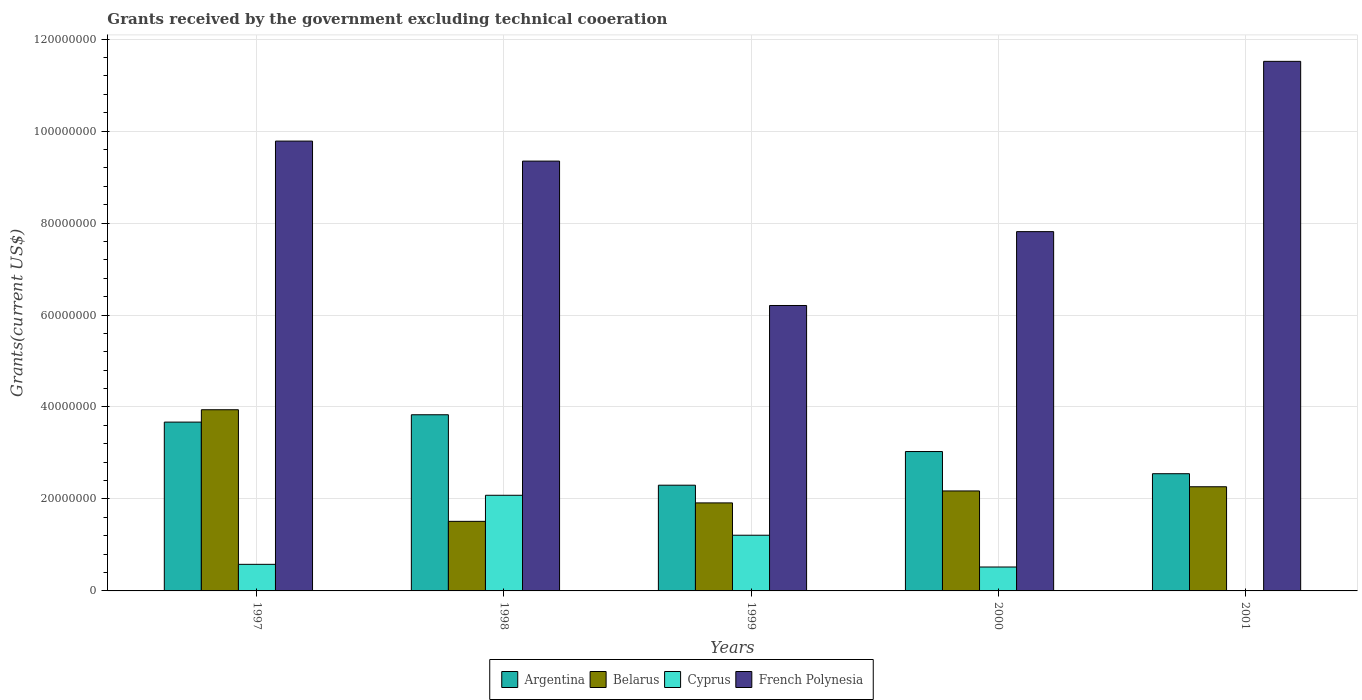How many bars are there on the 3rd tick from the left?
Offer a terse response. 4. What is the total grants received by the government in Cyprus in 1999?
Provide a succinct answer. 1.21e+07. Across all years, what is the maximum total grants received by the government in Belarus?
Offer a terse response. 3.94e+07. In which year was the total grants received by the government in Belarus maximum?
Keep it short and to the point. 1997. What is the total total grants received by the government in Belarus in the graph?
Ensure brevity in your answer.  1.18e+08. What is the difference between the total grants received by the government in French Polynesia in 1999 and that in 2001?
Offer a terse response. -5.31e+07. What is the difference between the total grants received by the government in French Polynesia in 2000 and the total grants received by the government in Belarus in 1999?
Provide a succinct answer. 5.90e+07. What is the average total grants received by the government in Cyprus per year?
Keep it short and to the point. 8.78e+06. In the year 2000, what is the difference between the total grants received by the government in Belarus and total grants received by the government in Cyprus?
Provide a succinct answer. 1.65e+07. In how many years, is the total grants received by the government in French Polynesia greater than 68000000 US$?
Your answer should be compact. 4. What is the ratio of the total grants received by the government in Argentina in 1997 to that in 2001?
Keep it short and to the point. 1.44. Is the difference between the total grants received by the government in Belarus in 1999 and 2000 greater than the difference between the total grants received by the government in Cyprus in 1999 and 2000?
Offer a very short reply. No. What is the difference between the highest and the second highest total grants received by the government in Argentina?
Offer a very short reply. 1.60e+06. What is the difference between the highest and the lowest total grants received by the government in Argentina?
Your response must be concise. 1.53e+07. Is it the case that in every year, the sum of the total grants received by the government in Belarus and total grants received by the government in Cyprus is greater than the sum of total grants received by the government in Argentina and total grants received by the government in French Polynesia?
Ensure brevity in your answer.  Yes. Is it the case that in every year, the sum of the total grants received by the government in Belarus and total grants received by the government in Cyprus is greater than the total grants received by the government in French Polynesia?
Make the answer very short. No. Are all the bars in the graph horizontal?
Ensure brevity in your answer.  No. What is the difference between two consecutive major ticks on the Y-axis?
Offer a terse response. 2.00e+07. Are the values on the major ticks of Y-axis written in scientific E-notation?
Keep it short and to the point. No. Does the graph contain any zero values?
Provide a short and direct response. Yes. Does the graph contain grids?
Provide a succinct answer. Yes. How are the legend labels stacked?
Provide a succinct answer. Horizontal. What is the title of the graph?
Offer a terse response. Grants received by the government excluding technical cooeration. What is the label or title of the X-axis?
Your answer should be compact. Years. What is the label or title of the Y-axis?
Provide a short and direct response. Grants(current US$). What is the Grants(current US$) in Argentina in 1997?
Make the answer very short. 3.67e+07. What is the Grants(current US$) of Belarus in 1997?
Offer a terse response. 3.94e+07. What is the Grants(current US$) of Cyprus in 1997?
Keep it short and to the point. 5.78e+06. What is the Grants(current US$) of French Polynesia in 1997?
Your answer should be very brief. 9.78e+07. What is the Grants(current US$) of Argentina in 1998?
Your answer should be compact. 3.83e+07. What is the Grants(current US$) of Belarus in 1998?
Ensure brevity in your answer.  1.51e+07. What is the Grants(current US$) of Cyprus in 1998?
Provide a short and direct response. 2.08e+07. What is the Grants(current US$) in French Polynesia in 1998?
Provide a succinct answer. 9.35e+07. What is the Grants(current US$) in Argentina in 1999?
Your answer should be compact. 2.30e+07. What is the Grants(current US$) in Belarus in 1999?
Give a very brief answer. 1.91e+07. What is the Grants(current US$) of Cyprus in 1999?
Give a very brief answer. 1.21e+07. What is the Grants(current US$) in French Polynesia in 1999?
Offer a terse response. 6.21e+07. What is the Grants(current US$) of Argentina in 2000?
Offer a very short reply. 3.03e+07. What is the Grants(current US$) in Belarus in 2000?
Provide a short and direct response. 2.17e+07. What is the Grants(current US$) of Cyprus in 2000?
Provide a succinct answer. 5.20e+06. What is the Grants(current US$) in French Polynesia in 2000?
Your response must be concise. 7.81e+07. What is the Grants(current US$) of Argentina in 2001?
Ensure brevity in your answer.  2.55e+07. What is the Grants(current US$) in Belarus in 2001?
Keep it short and to the point. 2.26e+07. What is the Grants(current US$) of Cyprus in 2001?
Your response must be concise. 0. What is the Grants(current US$) of French Polynesia in 2001?
Make the answer very short. 1.15e+08. Across all years, what is the maximum Grants(current US$) of Argentina?
Your response must be concise. 3.83e+07. Across all years, what is the maximum Grants(current US$) of Belarus?
Your response must be concise. 3.94e+07. Across all years, what is the maximum Grants(current US$) in Cyprus?
Ensure brevity in your answer.  2.08e+07. Across all years, what is the maximum Grants(current US$) of French Polynesia?
Your answer should be very brief. 1.15e+08. Across all years, what is the minimum Grants(current US$) in Argentina?
Ensure brevity in your answer.  2.30e+07. Across all years, what is the minimum Grants(current US$) of Belarus?
Make the answer very short. 1.51e+07. Across all years, what is the minimum Grants(current US$) of Cyprus?
Give a very brief answer. 0. Across all years, what is the minimum Grants(current US$) in French Polynesia?
Provide a succinct answer. 6.21e+07. What is the total Grants(current US$) in Argentina in the graph?
Your response must be concise. 1.54e+08. What is the total Grants(current US$) in Belarus in the graph?
Give a very brief answer. 1.18e+08. What is the total Grants(current US$) in Cyprus in the graph?
Provide a succinct answer. 4.39e+07. What is the total Grants(current US$) in French Polynesia in the graph?
Provide a succinct answer. 4.47e+08. What is the difference between the Grants(current US$) in Argentina in 1997 and that in 1998?
Offer a terse response. -1.60e+06. What is the difference between the Grants(current US$) of Belarus in 1997 and that in 1998?
Provide a succinct answer. 2.43e+07. What is the difference between the Grants(current US$) of Cyprus in 1997 and that in 1998?
Offer a terse response. -1.50e+07. What is the difference between the Grants(current US$) in French Polynesia in 1997 and that in 1998?
Ensure brevity in your answer.  4.35e+06. What is the difference between the Grants(current US$) in Argentina in 1997 and that in 1999?
Give a very brief answer. 1.37e+07. What is the difference between the Grants(current US$) of Belarus in 1997 and that in 1999?
Offer a terse response. 2.03e+07. What is the difference between the Grants(current US$) of Cyprus in 1997 and that in 1999?
Your answer should be compact. -6.33e+06. What is the difference between the Grants(current US$) of French Polynesia in 1997 and that in 1999?
Offer a very short reply. 3.58e+07. What is the difference between the Grants(current US$) of Argentina in 1997 and that in 2000?
Your response must be concise. 6.40e+06. What is the difference between the Grants(current US$) in Belarus in 1997 and that in 2000?
Ensure brevity in your answer.  1.77e+07. What is the difference between the Grants(current US$) of Cyprus in 1997 and that in 2000?
Your response must be concise. 5.80e+05. What is the difference between the Grants(current US$) in French Polynesia in 1997 and that in 2000?
Ensure brevity in your answer.  1.97e+07. What is the difference between the Grants(current US$) in Argentina in 1997 and that in 2001?
Ensure brevity in your answer.  1.12e+07. What is the difference between the Grants(current US$) in Belarus in 1997 and that in 2001?
Provide a succinct answer. 1.68e+07. What is the difference between the Grants(current US$) of French Polynesia in 1997 and that in 2001?
Your answer should be compact. -1.73e+07. What is the difference between the Grants(current US$) in Argentina in 1998 and that in 1999?
Provide a short and direct response. 1.53e+07. What is the difference between the Grants(current US$) in Belarus in 1998 and that in 1999?
Provide a succinct answer. -4.01e+06. What is the difference between the Grants(current US$) of Cyprus in 1998 and that in 1999?
Your answer should be compact. 8.69e+06. What is the difference between the Grants(current US$) of French Polynesia in 1998 and that in 1999?
Provide a succinct answer. 3.14e+07. What is the difference between the Grants(current US$) of Argentina in 1998 and that in 2000?
Ensure brevity in your answer.  8.00e+06. What is the difference between the Grants(current US$) in Belarus in 1998 and that in 2000?
Give a very brief answer. -6.61e+06. What is the difference between the Grants(current US$) of Cyprus in 1998 and that in 2000?
Make the answer very short. 1.56e+07. What is the difference between the Grants(current US$) in French Polynesia in 1998 and that in 2000?
Keep it short and to the point. 1.53e+07. What is the difference between the Grants(current US$) of Argentina in 1998 and that in 2001?
Provide a succinct answer. 1.28e+07. What is the difference between the Grants(current US$) in Belarus in 1998 and that in 2001?
Your answer should be very brief. -7.52e+06. What is the difference between the Grants(current US$) of French Polynesia in 1998 and that in 2001?
Keep it short and to the point. -2.17e+07. What is the difference between the Grants(current US$) in Argentina in 1999 and that in 2000?
Ensure brevity in your answer.  -7.32e+06. What is the difference between the Grants(current US$) of Belarus in 1999 and that in 2000?
Offer a very short reply. -2.60e+06. What is the difference between the Grants(current US$) in Cyprus in 1999 and that in 2000?
Ensure brevity in your answer.  6.91e+06. What is the difference between the Grants(current US$) in French Polynesia in 1999 and that in 2000?
Provide a short and direct response. -1.61e+07. What is the difference between the Grants(current US$) of Argentina in 1999 and that in 2001?
Provide a succinct answer. -2.50e+06. What is the difference between the Grants(current US$) of Belarus in 1999 and that in 2001?
Offer a very short reply. -3.51e+06. What is the difference between the Grants(current US$) in French Polynesia in 1999 and that in 2001?
Ensure brevity in your answer.  -5.31e+07. What is the difference between the Grants(current US$) in Argentina in 2000 and that in 2001?
Offer a very short reply. 4.82e+06. What is the difference between the Grants(current US$) in Belarus in 2000 and that in 2001?
Offer a terse response. -9.10e+05. What is the difference between the Grants(current US$) in French Polynesia in 2000 and that in 2001?
Provide a succinct answer. -3.70e+07. What is the difference between the Grants(current US$) of Argentina in 1997 and the Grants(current US$) of Belarus in 1998?
Give a very brief answer. 2.16e+07. What is the difference between the Grants(current US$) in Argentina in 1997 and the Grants(current US$) in Cyprus in 1998?
Your answer should be very brief. 1.59e+07. What is the difference between the Grants(current US$) of Argentina in 1997 and the Grants(current US$) of French Polynesia in 1998?
Offer a very short reply. -5.68e+07. What is the difference between the Grants(current US$) in Belarus in 1997 and the Grants(current US$) in Cyprus in 1998?
Offer a very short reply. 1.86e+07. What is the difference between the Grants(current US$) of Belarus in 1997 and the Grants(current US$) of French Polynesia in 1998?
Make the answer very short. -5.41e+07. What is the difference between the Grants(current US$) in Cyprus in 1997 and the Grants(current US$) in French Polynesia in 1998?
Offer a very short reply. -8.77e+07. What is the difference between the Grants(current US$) in Argentina in 1997 and the Grants(current US$) in Belarus in 1999?
Your response must be concise. 1.76e+07. What is the difference between the Grants(current US$) in Argentina in 1997 and the Grants(current US$) in Cyprus in 1999?
Offer a terse response. 2.46e+07. What is the difference between the Grants(current US$) in Argentina in 1997 and the Grants(current US$) in French Polynesia in 1999?
Give a very brief answer. -2.54e+07. What is the difference between the Grants(current US$) of Belarus in 1997 and the Grants(current US$) of Cyprus in 1999?
Make the answer very short. 2.73e+07. What is the difference between the Grants(current US$) in Belarus in 1997 and the Grants(current US$) in French Polynesia in 1999?
Your answer should be very brief. -2.27e+07. What is the difference between the Grants(current US$) of Cyprus in 1997 and the Grants(current US$) of French Polynesia in 1999?
Your answer should be compact. -5.63e+07. What is the difference between the Grants(current US$) in Argentina in 1997 and the Grants(current US$) in Belarus in 2000?
Offer a terse response. 1.50e+07. What is the difference between the Grants(current US$) of Argentina in 1997 and the Grants(current US$) of Cyprus in 2000?
Your response must be concise. 3.15e+07. What is the difference between the Grants(current US$) of Argentina in 1997 and the Grants(current US$) of French Polynesia in 2000?
Your response must be concise. -4.14e+07. What is the difference between the Grants(current US$) of Belarus in 1997 and the Grants(current US$) of Cyprus in 2000?
Offer a very short reply. 3.42e+07. What is the difference between the Grants(current US$) of Belarus in 1997 and the Grants(current US$) of French Polynesia in 2000?
Make the answer very short. -3.87e+07. What is the difference between the Grants(current US$) in Cyprus in 1997 and the Grants(current US$) in French Polynesia in 2000?
Offer a very short reply. -7.24e+07. What is the difference between the Grants(current US$) in Argentina in 1997 and the Grants(current US$) in Belarus in 2001?
Offer a terse response. 1.41e+07. What is the difference between the Grants(current US$) of Argentina in 1997 and the Grants(current US$) of French Polynesia in 2001?
Give a very brief answer. -7.84e+07. What is the difference between the Grants(current US$) of Belarus in 1997 and the Grants(current US$) of French Polynesia in 2001?
Offer a very short reply. -7.58e+07. What is the difference between the Grants(current US$) of Cyprus in 1997 and the Grants(current US$) of French Polynesia in 2001?
Ensure brevity in your answer.  -1.09e+08. What is the difference between the Grants(current US$) in Argentina in 1998 and the Grants(current US$) in Belarus in 1999?
Ensure brevity in your answer.  1.92e+07. What is the difference between the Grants(current US$) in Argentina in 1998 and the Grants(current US$) in Cyprus in 1999?
Your answer should be compact. 2.62e+07. What is the difference between the Grants(current US$) in Argentina in 1998 and the Grants(current US$) in French Polynesia in 1999?
Keep it short and to the point. -2.38e+07. What is the difference between the Grants(current US$) of Belarus in 1998 and the Grants(current US$) of Cyprus in 1999?
Ensure brevity in your answer.  3.02e+06. What is the difference between the Grants(current US$) of Belarus in 1998 and the Grants(current US$) of French Polynesia in 1999?
Provide a short and direct response. -4.69e+07. What is the difference between the Grants(current US$) of Cyprus in 1998 and the Grants(current US$) of French Polynesia in 1999?
Your response must be concise. -4.13e+07. What is the difference between the Grants(current US$) in Argentina in 1998 and the Grants(current US$) in Belarus in 2000?
Keep it short and to the point. 1.66e+07. What is the difference between the Grants(current US$) in Argentina in 1998 and the Grants(current US$) in Cyprus in 2000?
Make the answer very short. 3.31e+07. What is the difference between the Grants(current US$) in Argentina in 1998 and the Grants(current US$) in French Polynesia in 2000?
Keep it short and to the point. -3.98e+07. What is the difference between the Grants(current US$) of Belarus in 1998 and the Grants(current US$) of Cyprus in 2000?
Keep it short and to the point. 9.93e+06. What is the difference between the Grants(current US$) of Belarus in 1998 and the Grants(current US$) of French Polynesia in 2000?
Provide a succinct answer. -6.30e+07. What is the difference between the Grants(current US$) in Cyprus in 1998 and the Grants(current US$) in French Polynesia in 2000?
Make the answer very short. -5.73e+07. What is the difference between the Grants(current US$) in Argentina in 1998 and the Grants(current US$) in Belarus in 2001?
Your answer should be very brief. 1.57e+07. What is the difference between the Grants(current US$) in Argentina in 1998 and the Grants(current US$) in French Polynesia in 2001?
Provide a succinct answer. -7.68e+07. What is the difference between the Grants(current US$) of Belarus in 1998 and the Grants(current US$) of French Polynesia in 2001?
Offer a terse response. -1.00e+08. What is the difference between the Grants(current US$) in Cyprus in 1998 and the Grants(current US$) in French Polynesia in 2001?
Your answer should be very brief. -9.44e+07. What is the difference between the Grants(current US$) of Argentina in 1999 and the Grants(current US$) of Belarus in 2000?
Your response must be concise. 1.25e+06. What is the difference between the Grants(current US$) of Argentina in 1999 and the Grants(current US$) of Cyprus in 2000?
Your answer should be compact. 1.78e+07. What is the difference between the Grants(current US$) in Argentina in 1999 and the Grants(current US$) in French Polynesia in 2000?
Keep it short and to the point. -5.51e+07. What is the difference between the Grants(current US$) in Belarus in 1999 and the Grants(current US$) in Cyprus in 2000?
Give a very brief answer. 1.39e+07. What is the difference between the Grants(current US$) in Belarus in 1999 and the Grants(current US$) in French Polynesia in 2000?
Keep it short and to the point. -5.90e+07. What is the difference between the Grants(current US$) in Cyprus in 1999 and the Grants(current US$) in French Polynesia in 2000?
Give a very brief answer. -6.60e+07. What is the difference between the Grants(current US$) in Argentina in 1999 and the Grants(current US$) in French Polynesia in 2001?
Offer a very short reply. -9.22e+07. What is the difference between the Grants(current US$) of Belarus in 1999 and the Grants(current US$) of French Polynesia in 2001?
Offer a very short reply. -9.60e+07. What is the difference between the Grants(current US$) in Cyprus in 1999 and the Grants(current US$) in French Polynesia in 2001?
Provide a succinct answer. -1.03e+08. What is the difference between the Grants(current US$) of Argentina in 2000 and the Grants(current US$) of Belarus in 2001?
Keep it short and to the point. 7.66e+06. What is the difference between the Grants(current US$) in Argentina in 2000 and the Grants(current US$) in French Polynesia in 2001?
Make the answer very short. -8.48e+07. What is the difference between the Grants(current US$) of Belarus in 2000 and the Grants(current US$) of French Polynesia in 2001?
Your answer should be very brief. -9.34e+07. What is the difference between the Grants(current US$) of Cyprus in 2000 and the Grants(current US$) of French Polynesia in 2001?
Offer a very short reply. -1.10e+08. What is the average Grants(current US$) of Argentina per year?
Your response must be concise. 3.08e+07. What is the average Grants(current US$) of Belarus per year?
Offer a very short reply. 2.36e+07. What is the average Grants(current US$) in Cyprus per year?
Give a very brief answer. 8.78e+06. What is the average Grants(current US$) in French Polynesia per year?
Offer a very short reply. 8.93e+07. In the year 1997, what is the difference between the Grants(current US$) of Argentina and Grants(current US$) of Belarus?
Keep it short and to the point. -2.69e+06. In the year 1997, what is the difference between the Grants(current US$) in Argentina and Grants(current US$) in Cyprus?
Provide a short and direct response. 3.09e+07. In the year 1997, what is the difference between the Grants(current US$) of Argentina and Grants(current US$) of French Polynesia?
Offer a terse response. -6.11e+07. In the year 1997, what is the difference between the Grants(current US$) in Belarus and Grants(current US$) in Cyprus?
Provide a short and direct response. 3.36e+07. In the year 1997, what is the difference between the Grants(current US$) in Belarus and Grants(current US$) in French Polynesia?
Ensure brevity in your answer.  -5.84e+07. In the year 1997, what is the difference between the Grants(current US$) in Cyprus and Grants(current US$) in French Polynesia?
Make the answer very short. -9.20e+07. In the year 1998, what is the difference between the Grants(current US$) of Argentina and Grants(current US$) of Belarus?
Your response must be concise. 2.32e+07. In the year 1998, what is the difference between the Grants(current US$) of Argentina and Grants(current US$) of Cyprus?
Your answer should be very brief. 1.75e+07. In the year 1998, what is the difference between the Grants(current US$) in Argentina and Grants(current US$) in French Polynesia?
Offer a terse response. -5.52e+07. In the year 1998, what is the difference between the Grants(current US$) of Belarus and Grants(current US$) of Cyprus?
Provide a succinct answer. -5.67e+06. In the year 1998, what is the difference between the Grants(current US$) in Belarus and Grants(current US$) in French Polynesia?
Your response must be concise. -7.83e+07. In the year 1998, what is the difference between the Grants(current US$) in Cyprus and Grants(current US$) in French Polynesia?
Keep it short and to the point. -7.27e+07. In the year 1999, what is the difference between the Grants(current US$) in Argentina and Grants(current US$) in Belarus?
Your answer should be compact. 3.85e+06. In the year 1999, what is the difference between the Grants(current US$) of Argentina and Grants(current US$) of Cyprus?
Keep it short and to the point. 1.09e+07. In the year 1999, what is the difference between the Grants(current US$) in Argentina and Grants(current US$) in French Polynesia?
Provide a short and direct response. -3.91e+07. In the year 1999, what is the difference between the Grants(current US$) in Belarus and Grants(current US$) in Cyprus?
Give a very brief answer. 7.03e+06. In the year 1999, what is the difference between the Grants(current US$) in Belarus and Grants(current US$) in French Polynesia?
Offer a very short reply. -4.29e+07. In the year 1999, what is the difference between the Grants(current US$) of Cyprus and Grants(current US$) of French Polynesia?
Provide a short and direct response. -5.00e+07. In the year 2000, what is the difference between the Grants(current US$) in Argentina and Grants(current US$) in Belarus?
Provide a short and direct response. 8.57e+06. In the year 2000, what is the difference between the Grants(current US$) of Argentina and Grants(current US$) of Cyprus?
Your response must be concise. 2.51e+07. In the year 2000, what is the difference between the Grants(current US$) of Argentina and Grants(current US$) of French Polynesia?
Ensure brevity in your answer.  -4.78e+07. In the year 2000, what is the difference between the Grants(current US$) in Belarus and Grants(current US$) in Cyprus?
Offer a terse response. 1.65e+07. In the year 2000, what is the difference between the Grants(current US$) of Belarus and Grants(current US$) of French Polynesia?
Your response must be concise. -5.64e+07. In the year 2000, what is the difference between the Grants(current US$) in Cyprus and Grants(current US$) in French Polynesia?
Your answer should be very brief. -7.29e+07. In the year 2001, what is the difference between the Grants(current US$) of Argentina and Grants(current US$) of Belarus?
Provide a succinct answer. 2.84e+06. In the year 2001, what is the difference between the Grants(current US$) of Argentina and Grants(current US$) of French Polynesia?
Ensure brevity in your answer.  -8.97e+07. In the year 2001, what is the difference between the Grants(current US$) in Belarus and Grants(current US$) in French Polynesia?
Your answer should be compact. -9.25e+07. What is the ratio of the Grants(current US$) of Argentina in 1997 to that in 1998?
Your answer should be compact. 0.96. What is the ratio of the Grants(current US$) of Belarus in 1997 to that in 1998?
Your answer should be compact. 2.6. What is the ratio of the Grants(current US$) in Cyprus in 1997 to that in 1998?
Offer a terse response. 0.28. What is the ratio of the Grants(current US$) of French Polynesia in 1997 to that in 1998?
Make the answer very short. 1.05. What is the ratio of the Grants(current US$) of Argentina in 1997 to that in 1999?
Ensure brevity in your answer.  1.6. What is the ratio of the Grants(current US$) of Belarus in 1997 to that in 1999?
Offer a very short reply. 2.06. What is the ratio of the Grants(current US$) in Cyprus in 1997 to that in 1999?
Your answer should be very brief. 0.48. What is the ratio of the Grants(current US$) of French Polynesia in 1997 to that in 1999?
Provide a short and direct response. 1.58. What is the ratio of the Grants(current US$) in Argentina in 1997 to that in 2000?
Your answer should be compact. 1.21. What is the ratio of the Grants(current US$) in Belarus in 1997 to that in 2000?
Provide a succinct answer. 1.81. What is the ratio of the Grants(current US$) of Cyprus in 1997 to that in 2000?
Ensure brevity in your answer.  1.11. What is the ratio of the Grants(current US$) in French Polynesia in 1997 to that in 2000?
Your answer should be compact. 1.25. What is the ratio of the Grants(current US$) in Argentina in 1997 to that in 2001?
Your answer should be compact. 1.44. What is the ratio of the Grants(current US$) in Belarus in 1997 to that in 2001?
Make the answer very short. 1.74. What is the ratio of the Grants(current US$) in French Polynesia in 1997 to that in 2001?
Your answer should be very brief. 0.85. What is the ratio of the Grants(current US$) in Argentina in 1998 to that in 1999?
Provide a short and direct response. 1.67. What is the ratio of the Grants(current US$) of Belarus in 1998 to that in 1999?
Provide a succinct answer. 0.79. What is the ratio of the Grants(current US$) of Cyprus in 1998 to that in 1999?
Make the answer very short. 1.72. What is the ratio of the Grants(current US$) in French Polynesia in 1998 to that in 1999?
Provide a succinct answer. 1.51. What is the ratio of the Grants(current US$) in Argentina in 1998 to that in 2000?
Your answer should be compact. 1.26. What is the ratio of the Grants(current US$) of Belarus in 1998 to that in 2000?
Offer a very short reply. 0.7. What is the ratio of the Grants(current US$) of Cyprus in 1998 to that in 2000?
Offer a terse response. 4. What is the ratio of the Grants(current US$) of French Polynesia in 1998 to that in 2000?
Keep it short and to the point. 1.2. What is the ratio of the Grants(current US$) in Argentina in 1998 to that in 2001?
Offer a terse response. 1.5. What is the ratio of the Grants(current US$) of Belarus in 1998 to that in 2001?
Provide a short and direct response. 0.67. What is the ratio of the Grants(current US$) in French Polynesia in 1998 to that in 2001?
Make the answer very short. 0.81. What is the ratio of the Grants(current US$) in Argentina in 1999 to that in 2000?
Give a very brief answer. 0.76. What is the ratio of the Grants(current US$) in Belarus in 1999 to that in 2000?
Your answer should be very brief. 0.88. What is the ratio of the Grants(current US$) in Cyprus in 1999 to that in 2000?
Your response must be concise. 2.33. What is the ratio of the Grants(current US$) in French Polynesia in 1999 to that in 2000?
Provide a succinct answer. 0.79. What is the ratio of the Grants(current US$) of Argentina in 1999 to that in 2001?
Provide a short and direct response. 0.9. What is the ratio of the Grants(current US$) in Belarus in 1999 to that in 2001?
Provide a succinct answer. 0.84. What is the ratio of the Grants(current US$) of French Polynesia in 1999 to that in 2001?
Keep it short and to the point. 0.54. What is the ratio of the Grants(current US$) of Argentina in 2000 to that in 2001?
Make the answer very short. 1.19. What is the ratio of the Grants(current US$) of Belarus in 2000 to that in 2001?
Your response must be concise. 0.96. What is the ratio of the Grants(current US$) in French Polynesia in 2000 to that in 2001?
Your answer should be very brief. 0.68. What is the difference between the highest and the second highest Grants(current US$) of Argentina?
Offer a very short reply. 1.60e+06. What is the difference between the highest and the second highest Grants(current US$) in Belarus?
Your answer should be very brief. 1.68e+07. What is the difference between the highest and the second highest Grants(current US$) of Cyprus?
Provide a short and direct response. 8.69e+06. What is the difference between the highest and the second highest Grants(current US$) of French Polynesia?
Keep it short and to the point. 1.73e+07. What is the difference between the highest and the lowest Grants(current US$) in Argentina?
Offer a terse response. 1.53e+07. What is the difference between the highest and the lowest Grants(current US$) of Belarus?
Offer a very short reply. 2.43e+07. What is the difference between the highest and the lowest Grants(current US$) of Cyprus?
Offer a very short reply. 2.08e+07. What is the difference between the highest and the lowest Grants(current US$) of French Polynesia?
Make the answer very short. 5.31e+07. 